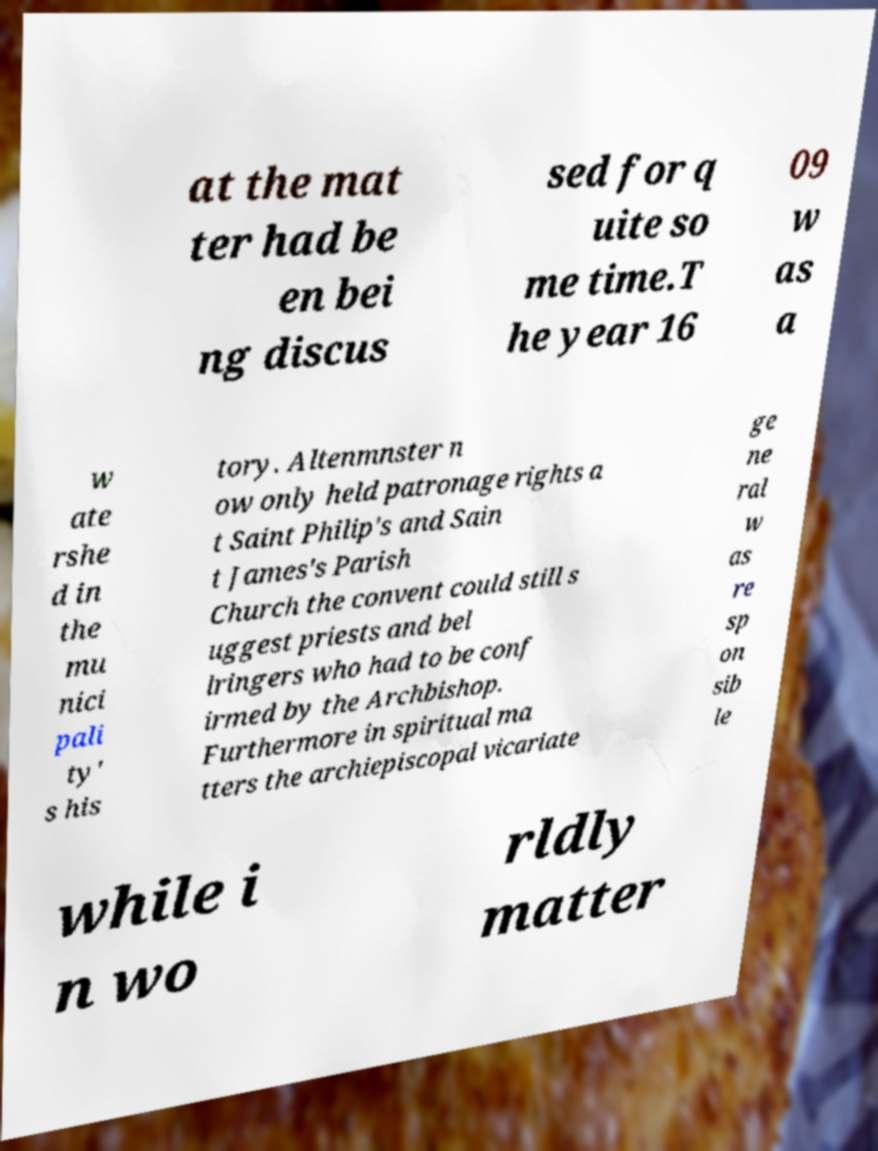Please identify and transcribe the text found in this image. at the mat ter had be en bei ng discus sed for q uite so me time.T he year 16 09 w as a w ate rshe d in the mu nici pali ty' s his tory. Altenmnster n ow only held patronage rights a t Saint Philip's and Sain t James's Parish Church the convent could still s uggest priests and bel lringers who had to be conf irmed by the Archbishop. Furthermore in spiritual ma tters the archiepiscopal vicariate ge ne ral w as re sp on sib le while i n wo rldly matter 